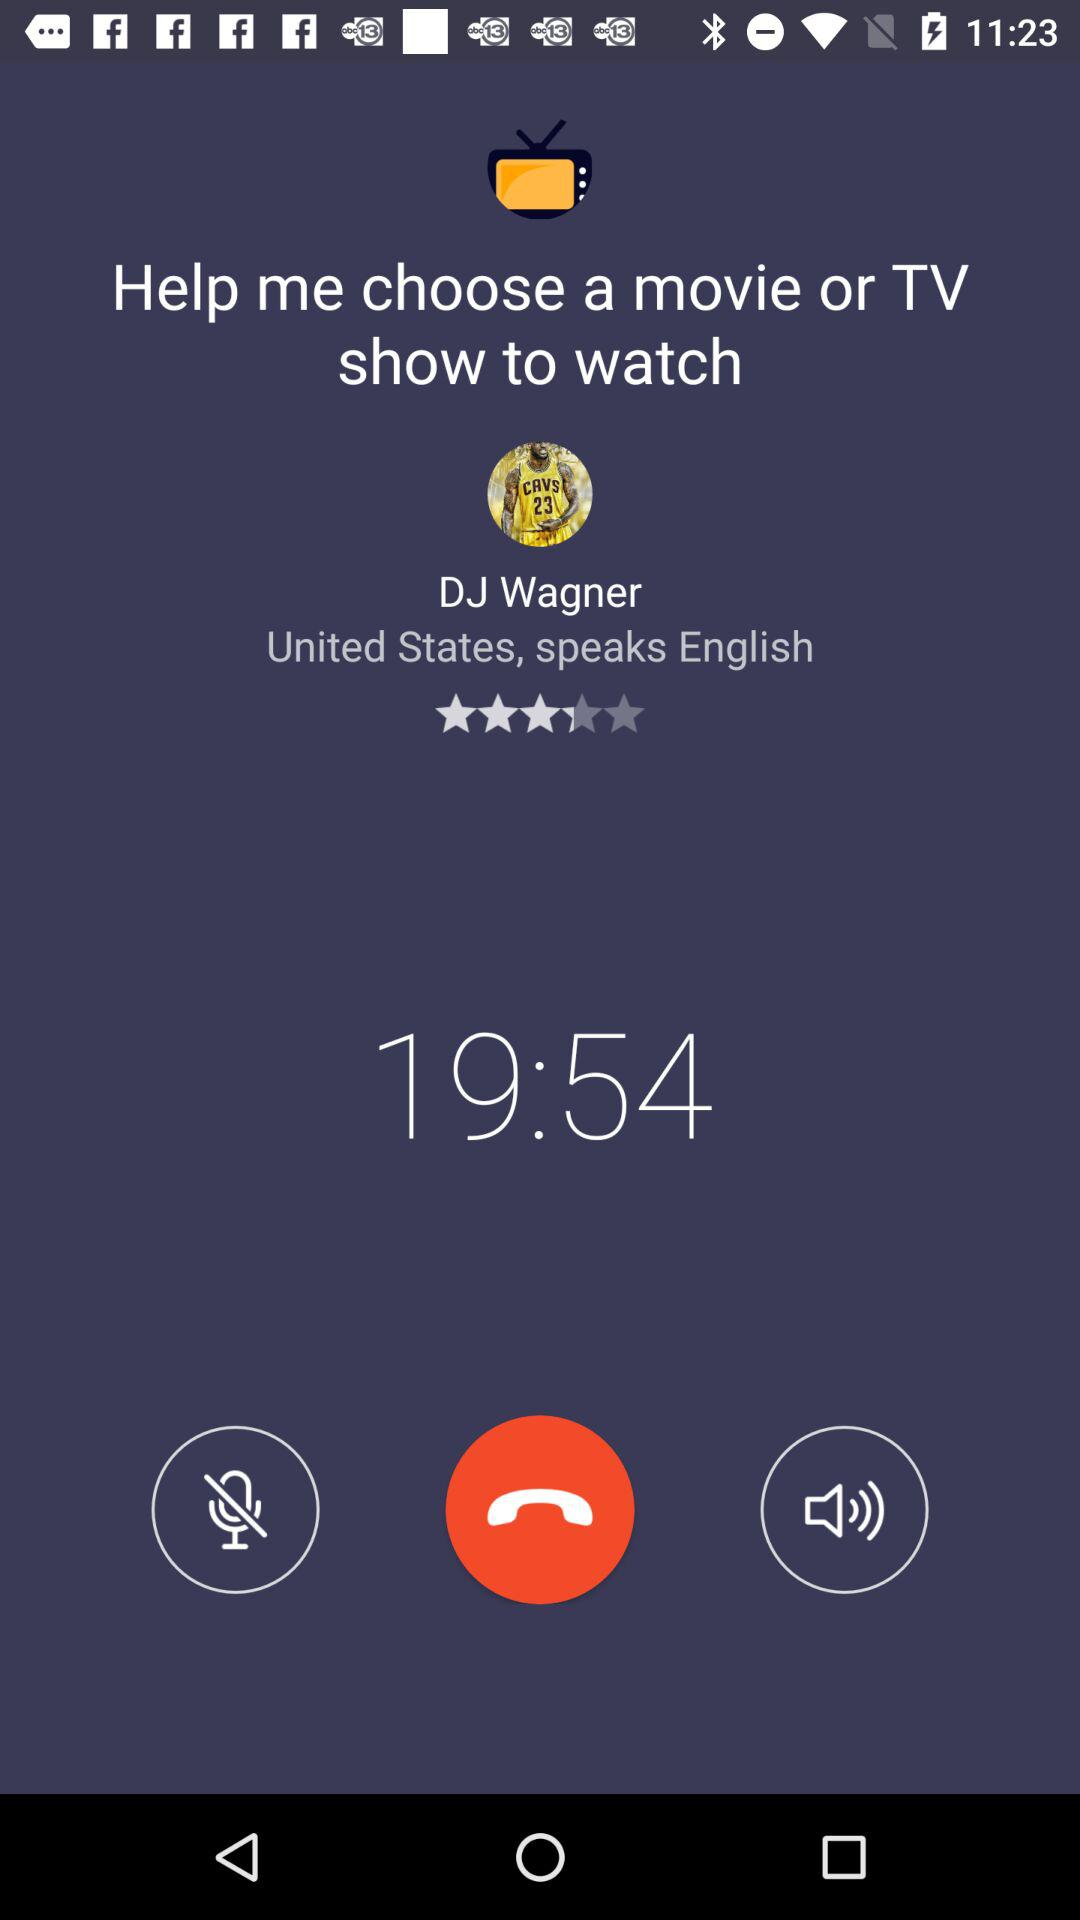What is the country name? The country name is the United States. 